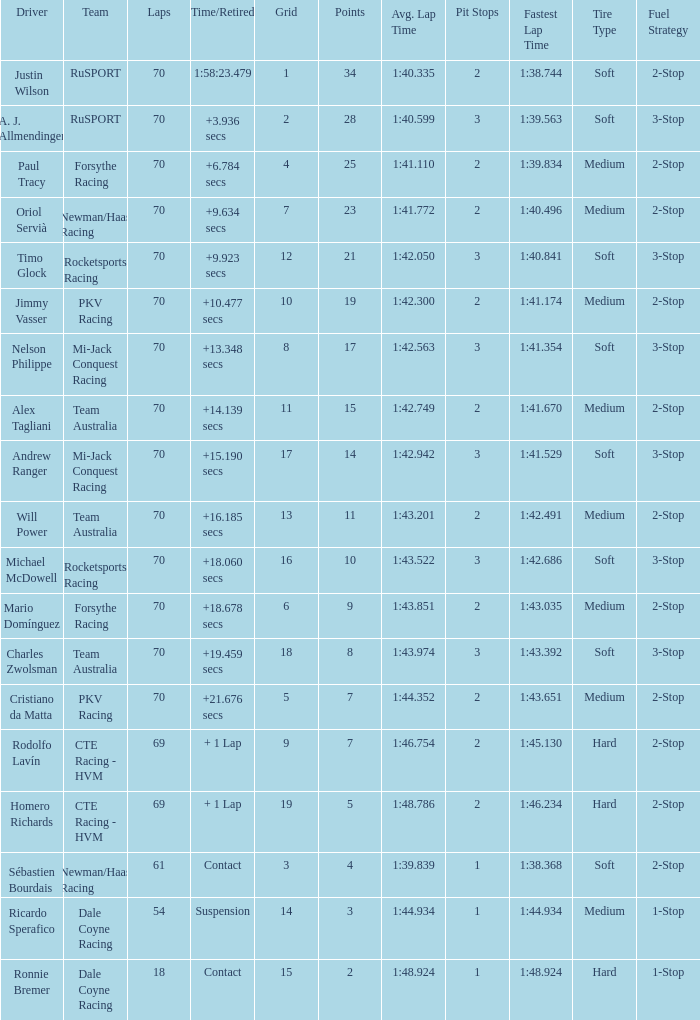Who scored with a grid of 10 and the highest amount of laps? 70.0. Would you be able to parse every entry in this table? {'header': ['Driver', 'Team', 'Laps', 'Time/Retired', 'Grid', 'Points', 'Avg. Lap Time', 'Pit Stops', 'Fastest Lap Time', 'Tire Type', 'Fuel Strategy'], 'rows': [['Justin Wilson', 'RuSPORT', '70', '1:58:23.479', '1', '34', '1:40.335', '2', '1:38.744', 'Soft', '2-Stop'], ['A. J. Allmendinger', 'RuSPORT', '70', '+3.936 secs', '2', '28', '1:40.599', '3', '1:39.563', 'Soft', '3-Stop'], ['Paul Tracy', 'Forsythe Racing', '70', '+6.784 secs', '4', '25', '1:41.110', '2', '1:39.834', 'Medium', '2-Stop'], ['Oriol Servià', 'Newman/Haas Racing', '70', '+9.634 secs', '7', '23', '1:41.772', '2', '1:40.496', 'Medium', '2-Stop'], ['Timo Glock', 'Rocketsports Racing', '70', '+9.923 secs', '12', '21', '1:42.050', '3', '1:40.841', 'Soft', '3-Stop'], ['Jimmy Vasser', 'PKV Racing', '70', '+10.477 secs', '10', '19', '1:42.300', '2', '1:41.174', 'Medium', '2-Stop'], ['Nelson Philippe', 'Mi-Jack Conquest Racing', '70', '+13.348 secs', '8', '17', '1:42.563', '3', '1:41.354', 'Soft', '3-Stop'], ['Alex Tagliani', 'Team Australia', '70', '+14.139 secs', '11', '15', '1:42.749', '2', '1:41.670', 'Medium', '2-Stop'], ['Andrew Ranger', 'Mi-Jack Conquest Racing', '70', '+15.190 secs', '17', '14', '1:42.942', '3', '1:41.529', 'Soft', '3-Stop'], ['Will Power', 'Team Australia', '70', '+16.185 secs', '13', '11', '1:43.201', '2', '1:42.491', 'Medium', '2-Stop'], ['Michael McDowell', 'Rocketsports Racing', '70', '+18.060 secs', '16', '10', '1:43.522', '3', '1:42.686', 'Soft', '3-Stop'], ['Mario Domínguez', 'Forsythe Racing', '70', '+18.678 secs', '6', '9', '1:43.851', '2', '1:43.035', 'Medium', '2-Stop'], ['Charles Zwolsman', 'Team Australia', '70', '+19.459 secs', '18', '8', '1:43.974', '3', '1:43.392', 'Soft', '3-Stop'], ['Cristiano da Matta', 'PKV Racing', '70', '+21.676 secs', '5', '7', '1:44.352', '2', '1:43.651', 'Medium', '2-Stop'], ['Rodolfo Lavín', 'CTE Racing - HVM', '69', '+ 1 Lap', '9', '7', '1:46.754', '2', '1:45.130', 'Hard', '2-Stop'], ['Homero Richards', 'CTE Racing - HVM', '69', '+ 1 Lap', '19', '5', '1:48.786', '2', '1:46.234', 'Hard', '2-Stop'], ['Sébastien Bourdais', 'Newman/Haas Racing', '61', 'Contact', '3', '4', '1:39.839', '1', '1:38.368', 'Soft', '2-Stop'], ['Ricardo Sperafico', 'Dale Coyne Racing', '54', 'Suspension', '14', '3', '1:44.934', '1', '1:44.934', 'Medium', '1-Stop'], ['Ronnie Bremer', 'Dale Coyne Racing', '18', 'Contact', '15', '2', '1:48.924', '1', '1:48.924', 'Hard', '1-Stop']]} 